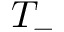<formula> <loc_0><loc_0><loc_500><loc_500>T _ { - }</formula> 